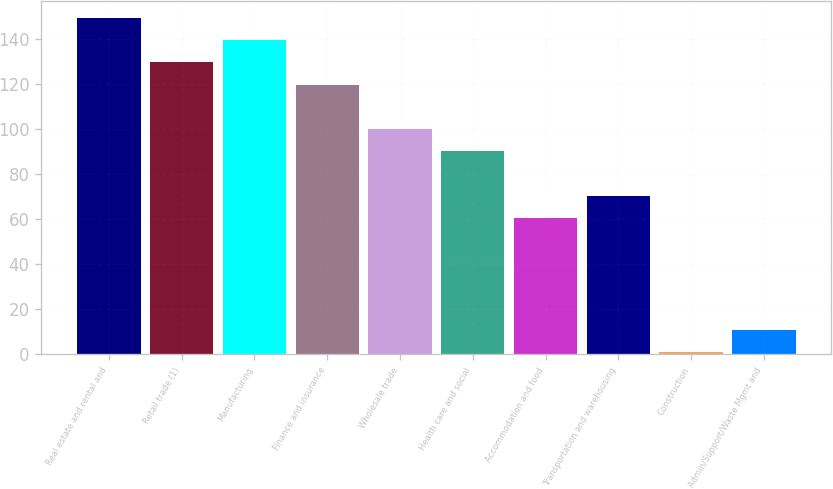Convert chart. <chart><loc_0><loc_0><loc_500><loc_500><bar_chart><fcel>Real estate and rental and<fcel>Retail trade (1)<fcel>Manufacturing<fcel>Finance and insurance<fcel>Wholesale trade<fcel>Health care and social<fcel>Accommodation and food<fcel>Transportation and warehousing<fcel>Construction<fcel>Admin/Support/Waste Mgmt and<nl><fcel>149.5<fcel>129.7<fcel>139.6<fcel>119.8<fcel>100<fcel>90.1<fcel>60.4<fcel>70.3<fcel>1<fcel>10.9<nl></chart> 